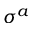<formula> <loc_0><loc_0><loc_500><loc_500>\sigma ^ { a }</formula> 